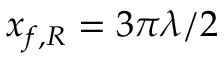<formula> <loc_0><loc_0><loc_500><loc_500>x _ { f , R } = 3 \pi \lambda / 2</formula> 